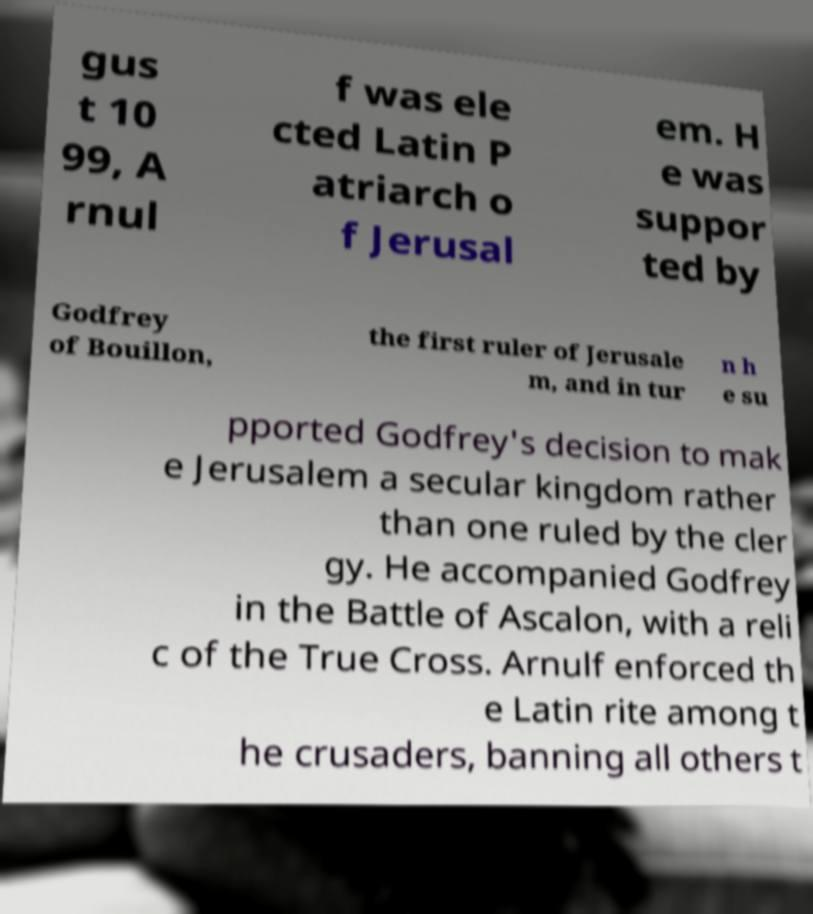Can you read and provide the text displayed in the image?This photo seems to have some interesting text. Can you extract and type it out for me? gus t 10 99, A rnul f was ele cted Latin P atriarch o f Jerusal em. H e was suppor ted by Godfrey of Bouillon, the first ruler of Jerusale m, and in tur n h e su pported Godfrey's decision to mak e Jerusalem a secular kingdom rather than one ruled by the cler gy. He accompanied Godfrey in the Battle of Ascalon, with a reli c of the True Cross. Arnulf enforced th e Latin rite among t he crusaders, banning all others t 